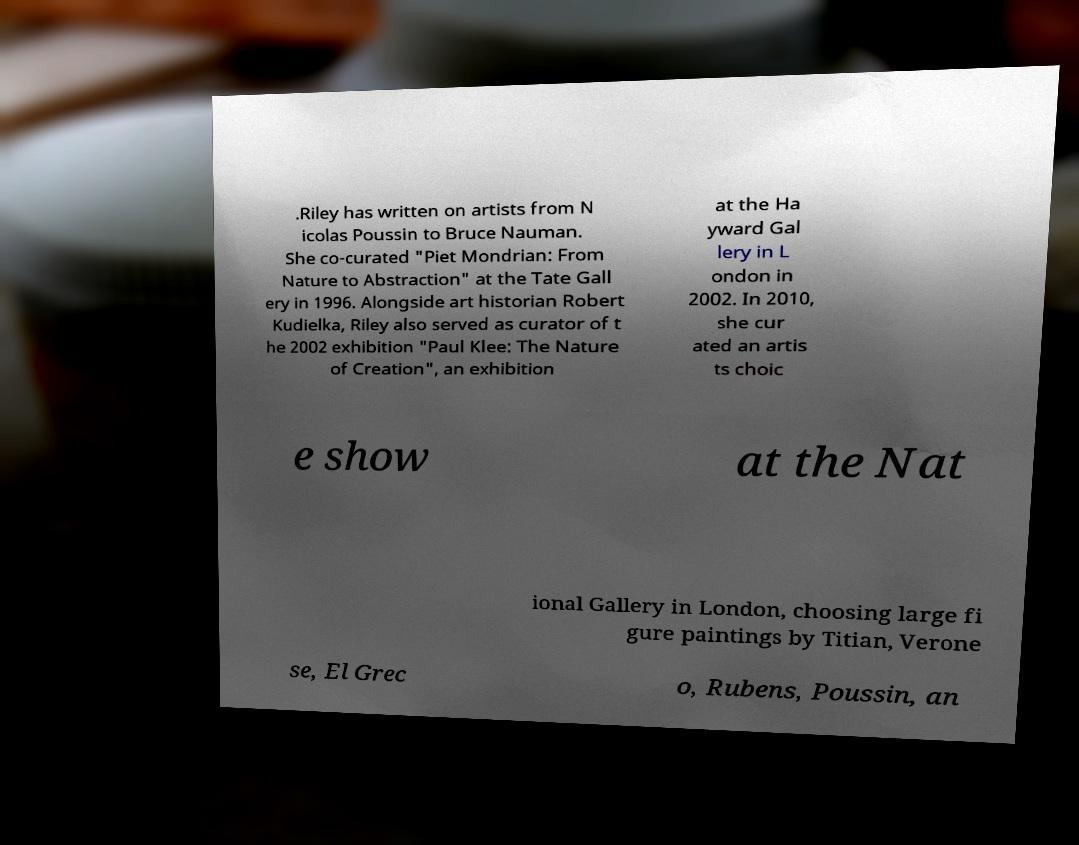Can you read and provide the text displayed in the image?This photo seems to have some interesting text. Can you extract and type it out for me? .Riley has written on artists from N icolas Poussin to Bruce Nauman. She co-curated "Piet Mondrian: From Nature to Abstraction" at the Tate Gall ery in 1996. Alongside art historian Robert Kudielka, Riley also served as curator of t he 2002 exhibition "Paul Klee: The Nature of Creation", an exhibition at the Ha yward Gal lery in L ondon in 2002. In 2010, she cur ated an artis ts choic e show at the Nat ional Gallery in London, choosing large fi gure paintings by Titian, Verone se, El Grec o, Rubens, Poussin, an 